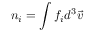<formula> <loc_0><loc_0><loc_500><loc_500>n _ { i } = \int f _ { i } d ^ { 3 } \vec { v }</formula> 